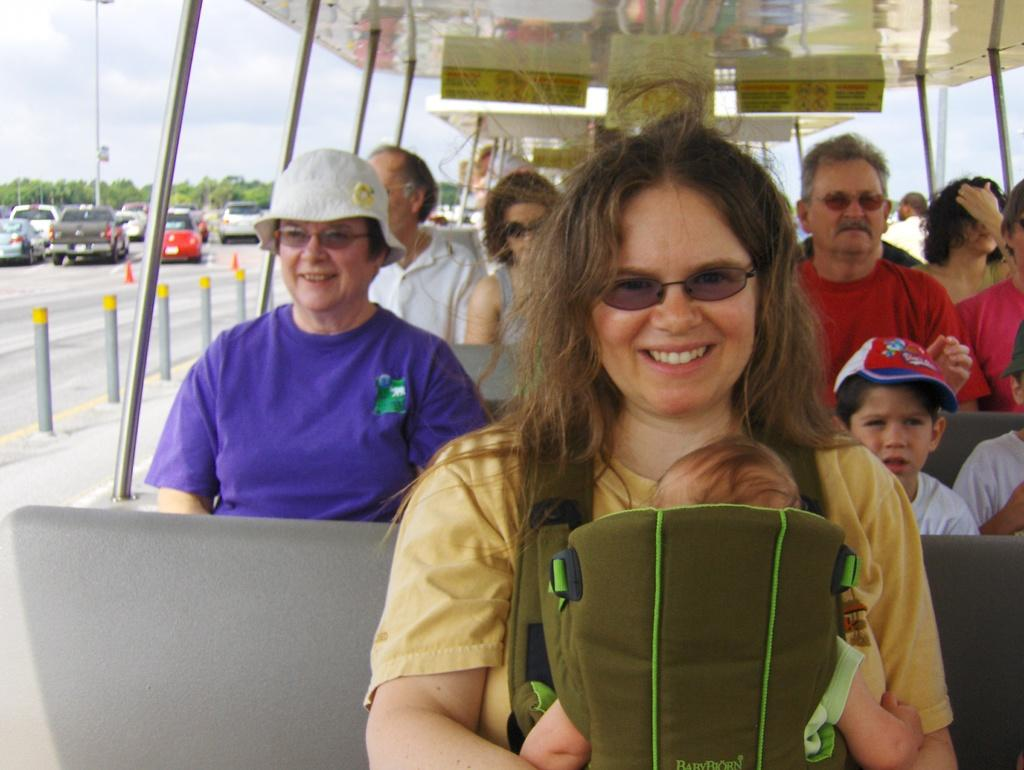How many persons are in the vehicle in the image? There are many persons sitting in the vehicle in the image. What can be seen in the background of the image? There are vehicles, a road, a pole, trees, and the sky visible in the background of the image. What is the condition of the sky in the image? The sky is visible in the background of the image, and clouds are present in the sky. What type of class is being held in the vehicle in the image? There is no class being held in the vehicle in the image; it is a vehicle with many persons sitting inside. 